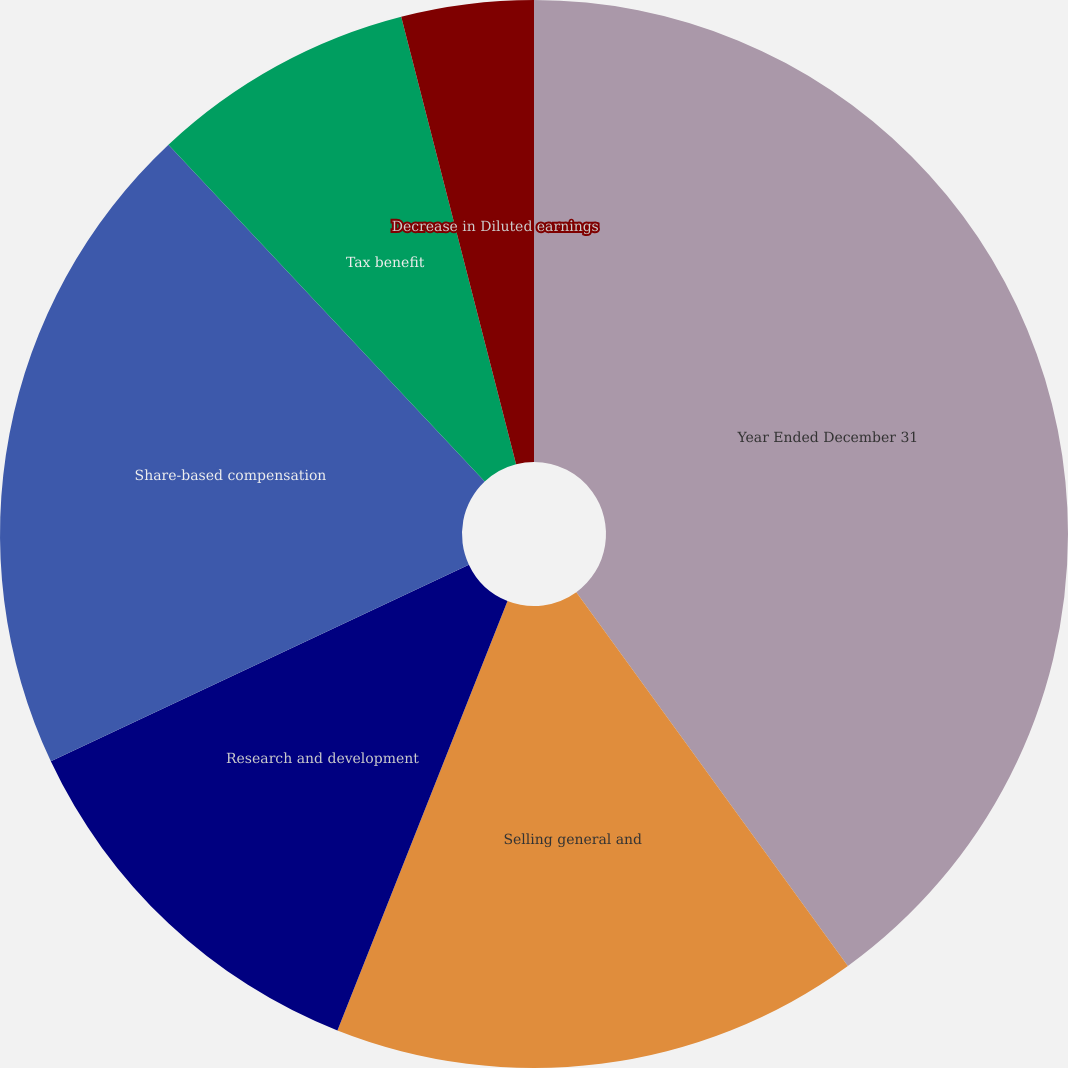Convert chart to OTSL. <chart><loc_0><loc_0><loc_500><loc_500><pie_chart><fcel>Year Ended December 31<fcel>Selling general and<fcel>Research and development<fcel>Share-based compensation<fcel>Tax benefit<fcel>Decrease in Basic earnings per<fcel>Decrease in Diluted earnings<nl><fcel>40.0%<fcel>16.0%<fcel>12.0%<fcel>20.0%<fcel>8.0%<fcel>0.0%<fcel>4.0%<nl></chart> 